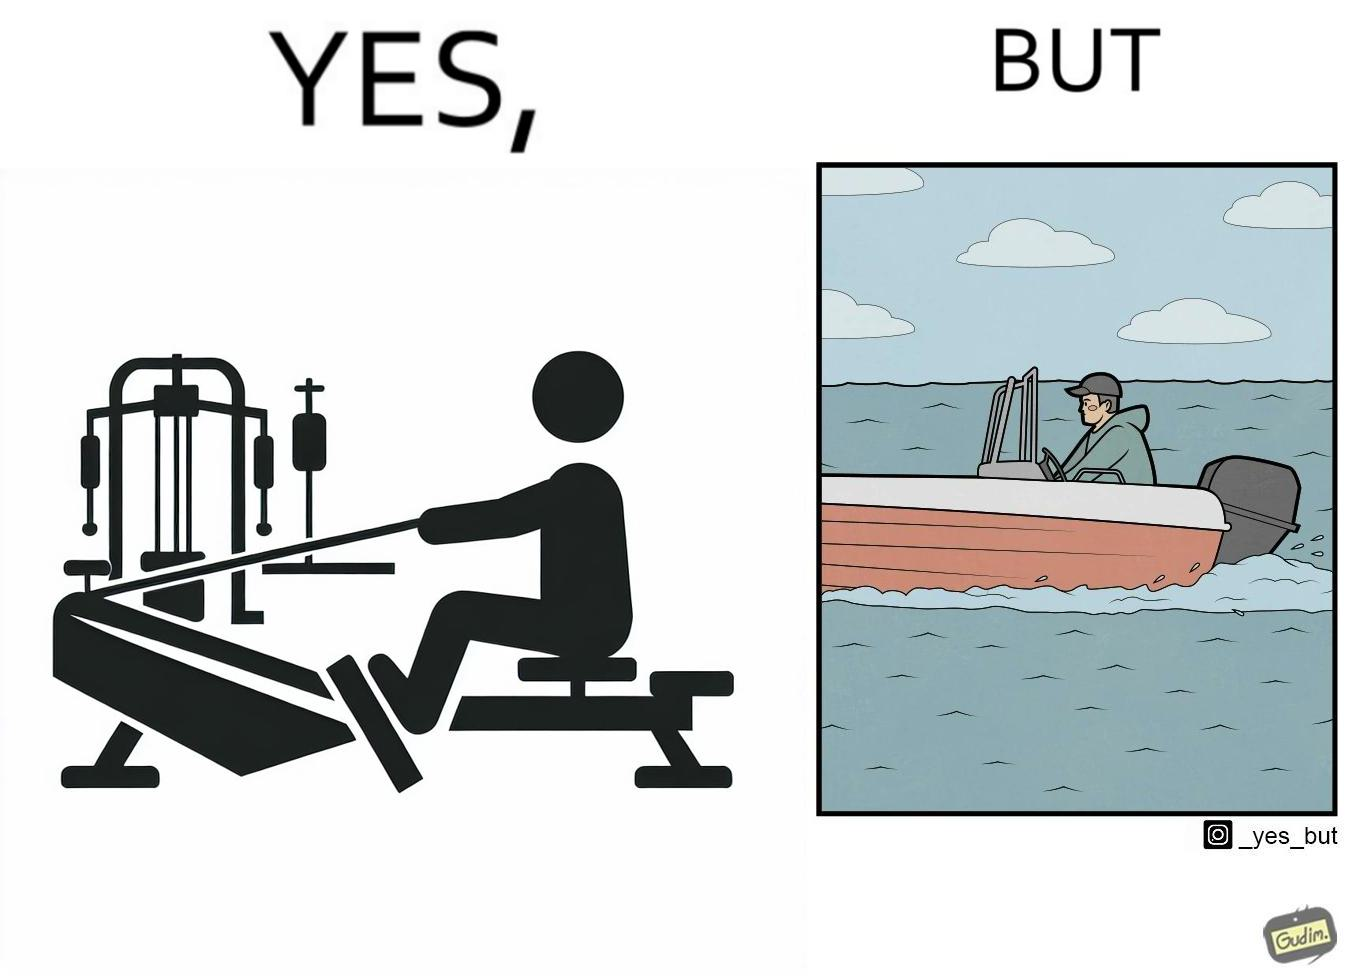Compare the left and right sides of this image. In the left part of the image: a person doing rowing exercise in gym In the right part of the image: a person riding a motorboat 